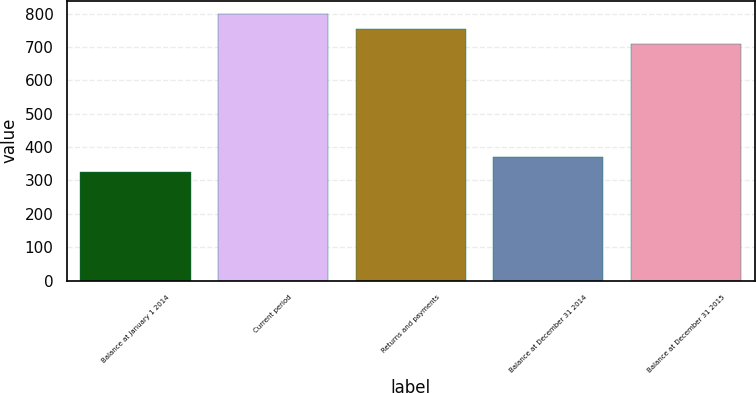Convert chart. <chart><loc_0><loc_0><loc_500><loc_500><bar_chart><fcel>Balance at January 1 2014<fcel>Current period<fcel>Returns and payments<fcel>Balance at December 31 2014<fcel>Balance at December 31 2015<nl><fcel>324<fcel>799.4<fcel>754.2<fcel>369.2<fcel>709<nl></chart> 